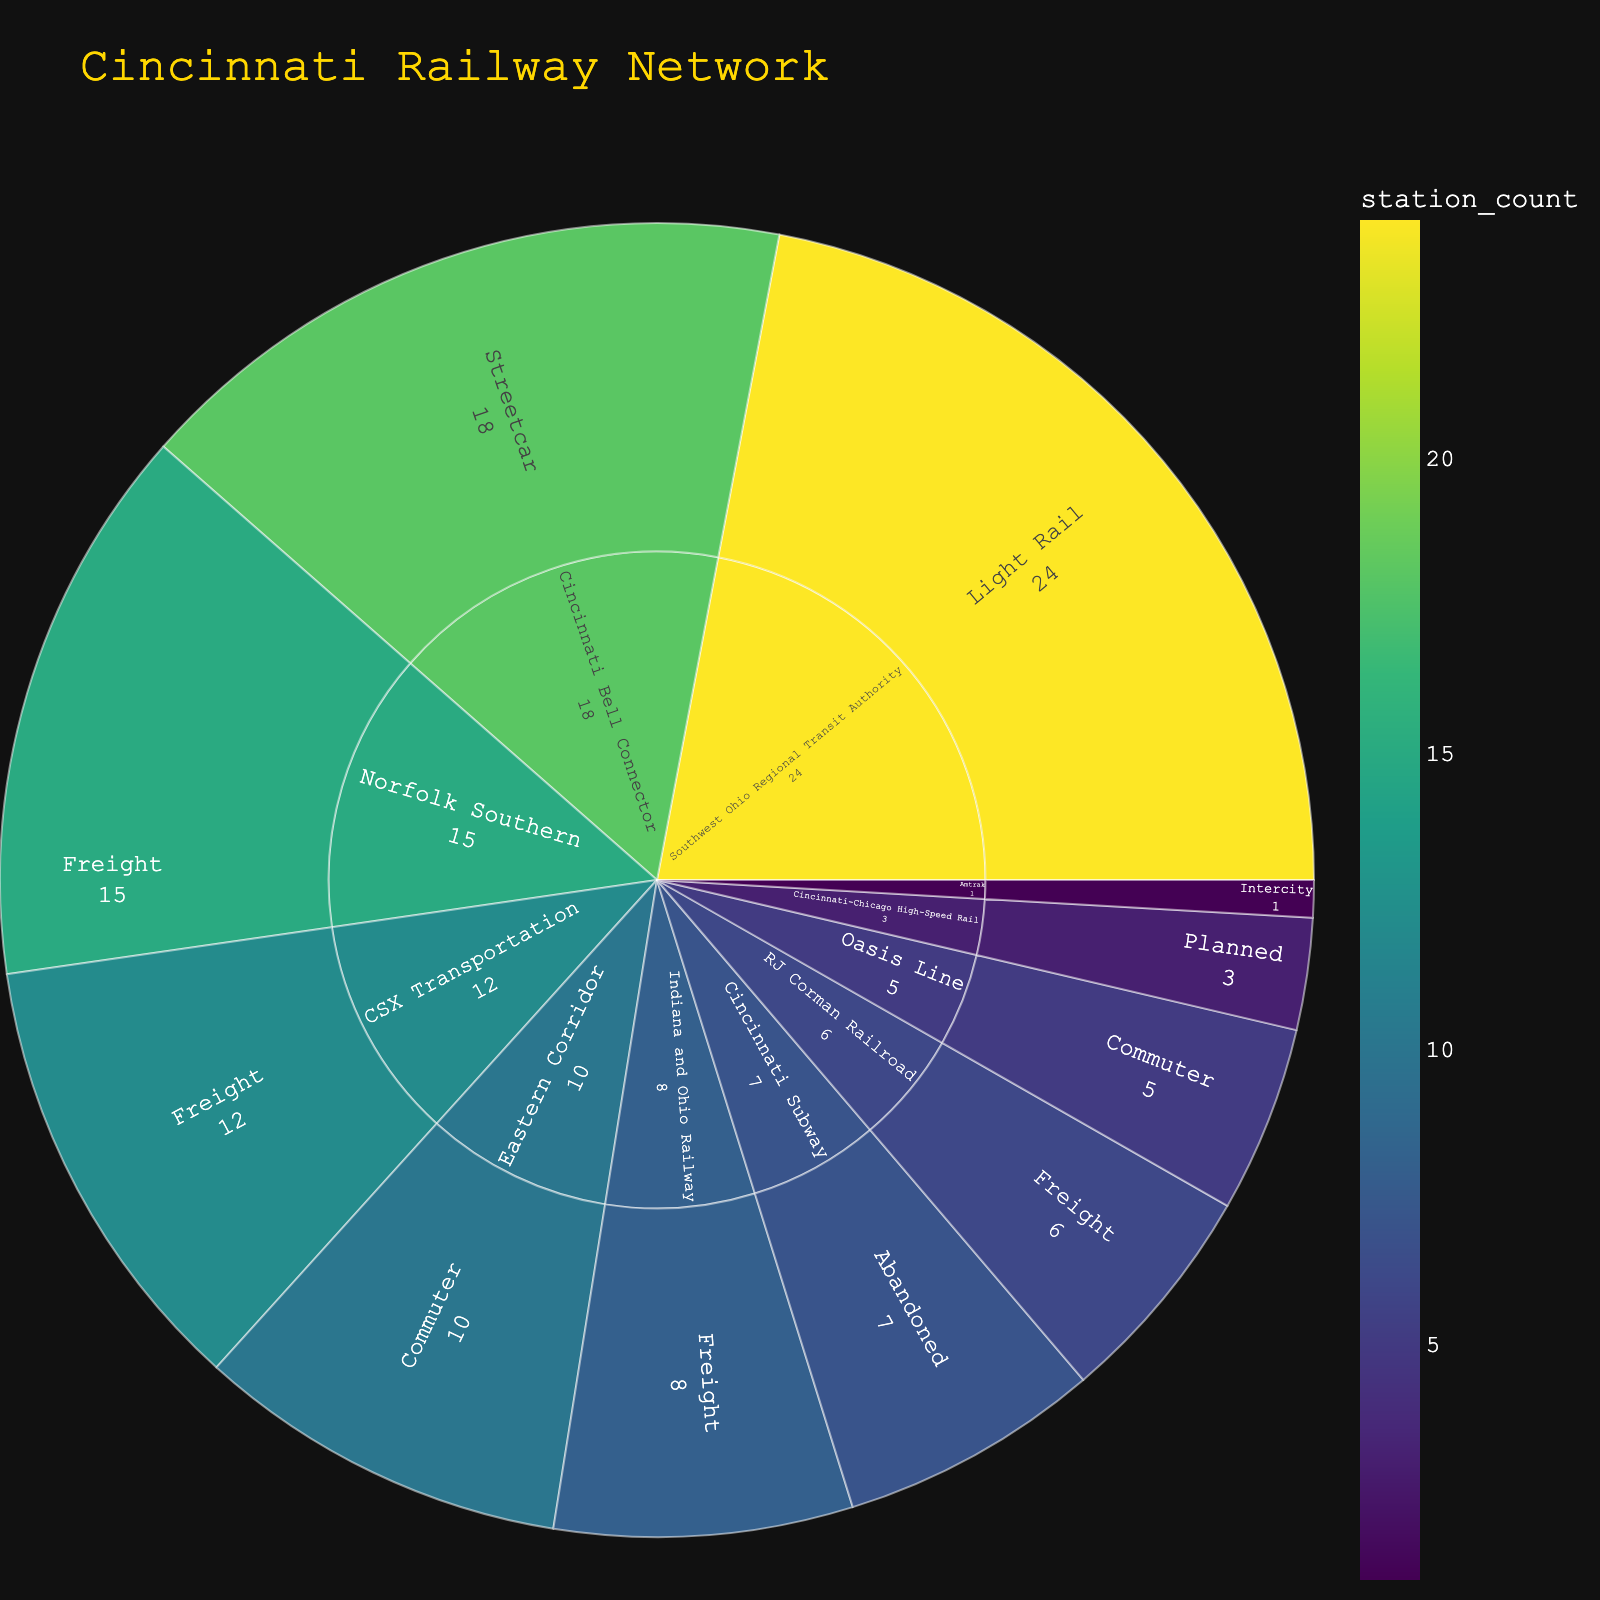What is the title of the plot? The title of the plot can be found at the top of the figure and is usually in a larger font size for easy identification.
Answer: Cincinnati Railway Network Which operator has the most stations, and what is the type of their line? Observing the data in the sunburst plot, count the number of stations for each operator. The operator with the highest count is the winner. Note the line type associated with this operator from the inner circle to the outer circle.
Answer: Southwest Ohio Regional Transit Authority, Light Rail How many freight line operators are there? Identify the segments labeled as "Freight" in the plot. Count the number of unique operators that feed into the "Freight" category in the inner circle.
Answer: 4 Which line type has the fewest stations, and how many are there? Navigate through the sunburst sections and find the line type with the smallest value associated with it.
Answer: Cincinnati-Chicago High-Speed Rail, Planned, 3 Compare the number of stations of the Cincinnati Bell Connector to the Southwest Ohio Regional Transit Authority. Which has more, and by how much? Find the segments for both Cincinnati Bell Connector and Southwest Ohio Regional Transit Authority. Subtract the station count of Cincinnati Bell Connector from the Southwest Ohio Regional Transit Authority's count.
Answer: Southwest Ohio Regional Transit Authority has 6 more stations (24 - 18 = 6) Sum up the total number of commuter stations. Locate all segments labeled as "Commuter" and sum their station counts.
Answer: 15 (5 for Oasis Line + 10 for Eastern Corridor) What is the combined number of stations for all freight operators? Locate the freight segments, sum their station counts.
Answer: 41 (12 for CSX Transportation + 15 for Norfolk Southern + 8 for Indiana and Ohio Railway + 6 for RJ Corman Railroad) Which has more stations: the abandoned Cincinnati Subway or the planned Cincinnati-Chicago High-Speed Rail? Compare the station counts of the "Cincinnati Subway" (Abandoned) and "Cincinnati-Chicago High-Speed Rail" (Planned). Identify the larger value.
Answer: Cincinnati Subway Approximately, what proportion of stations does the Amtrak line represent out of the total stations depicted? Identify the station count for Amtrak and sum the total station counts for all segments. Divide Amtrak's station count by the total and express as a percentage.
Answer: Approximately 1.35% (1 out of 74) Which operator has the most diverse types of line categories? For each operator, count how many unique line types they have. The operator with the highest count has the most diverse types.
Answer: Southwest Ohio Regional Transit Authority 